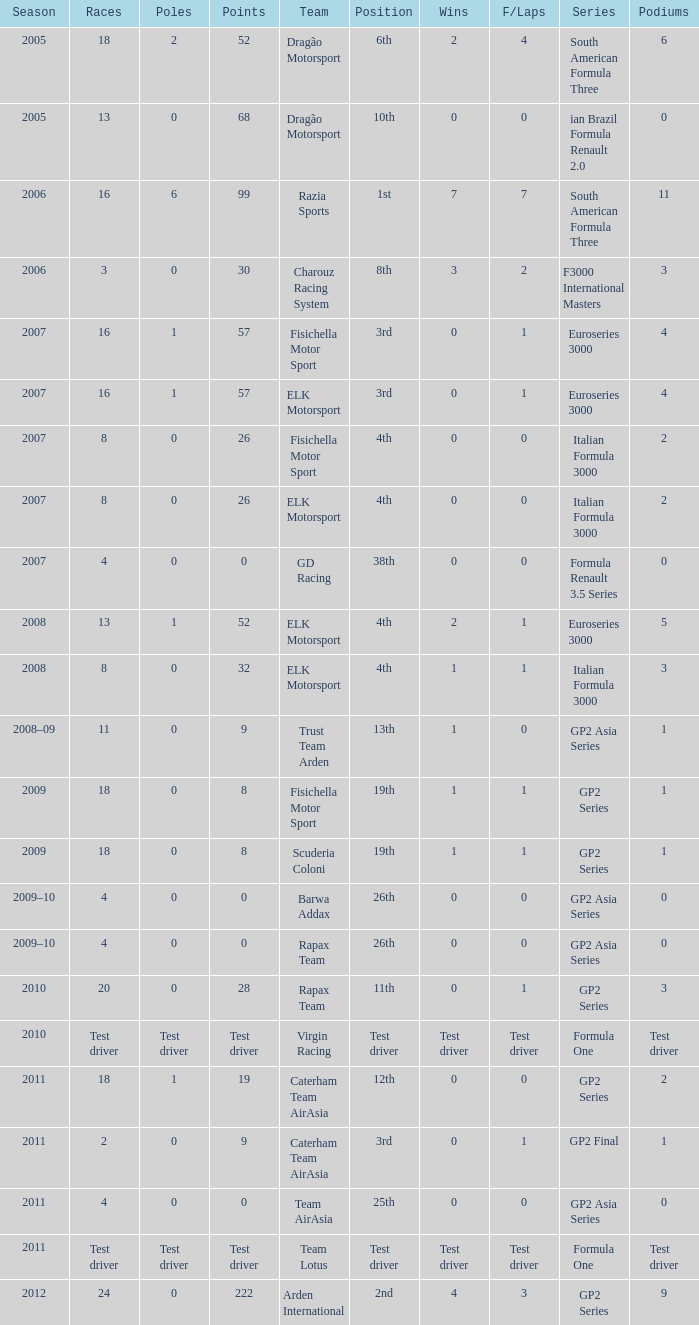In which season did he have 0 Poles and 19th position in the GP2 Series? 2009, 2009. 